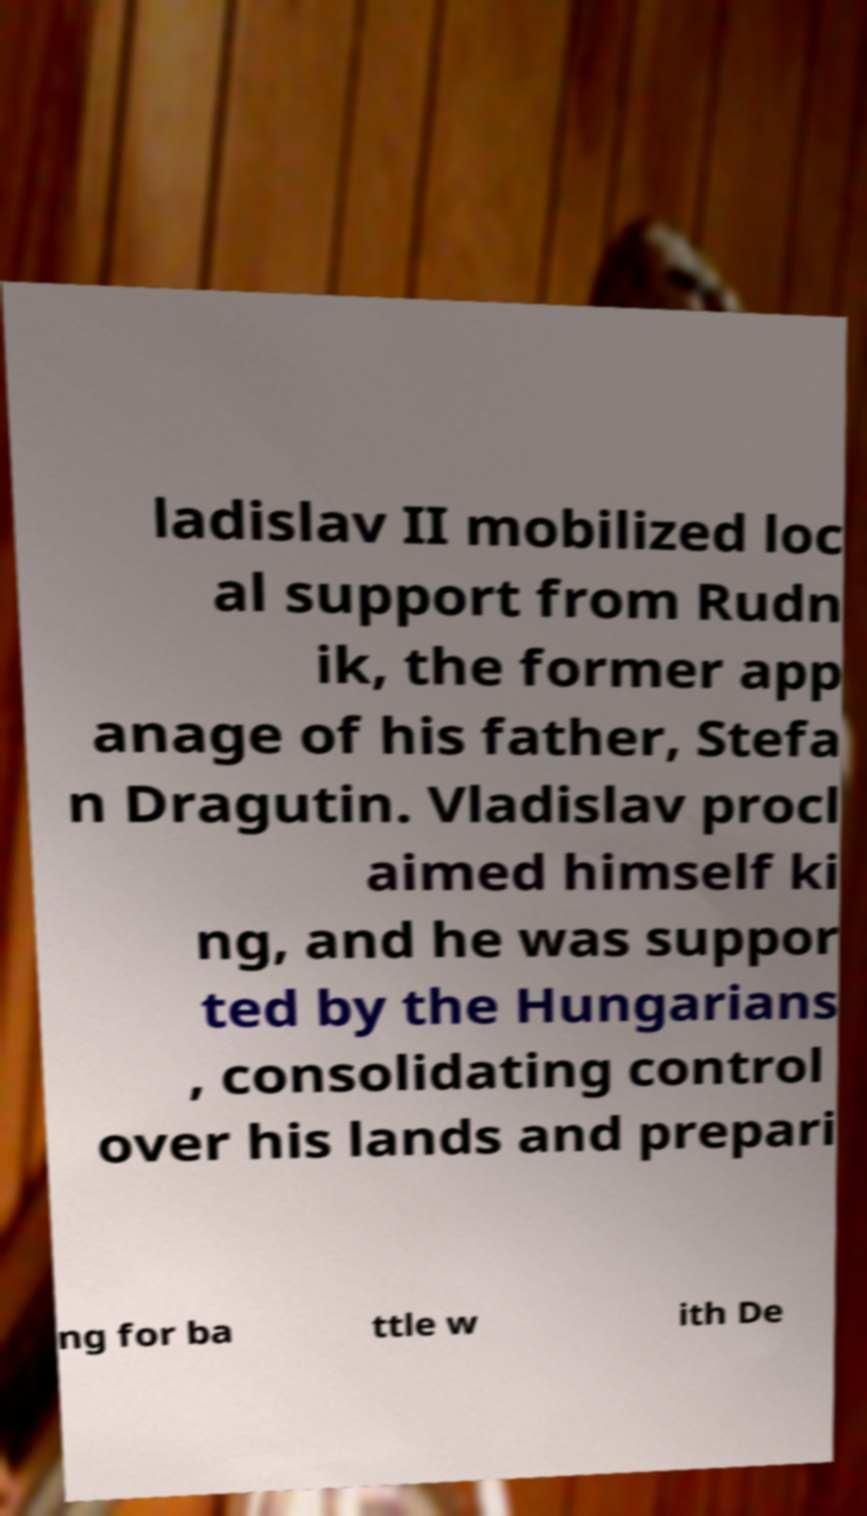Can you read and provide the text displayed in the image?This photo seems to have some interesting text. Can you extract and type it out for me? ladislav II mobilized loc al support from Rudn ik, the former app anage of his father, Stefa n Dragutin. Vladislav procl aimed himself ki ng, and he was suppor ted by the Hungarians , consolidating control over his lands and prepari ng for ba ttle w ith De 